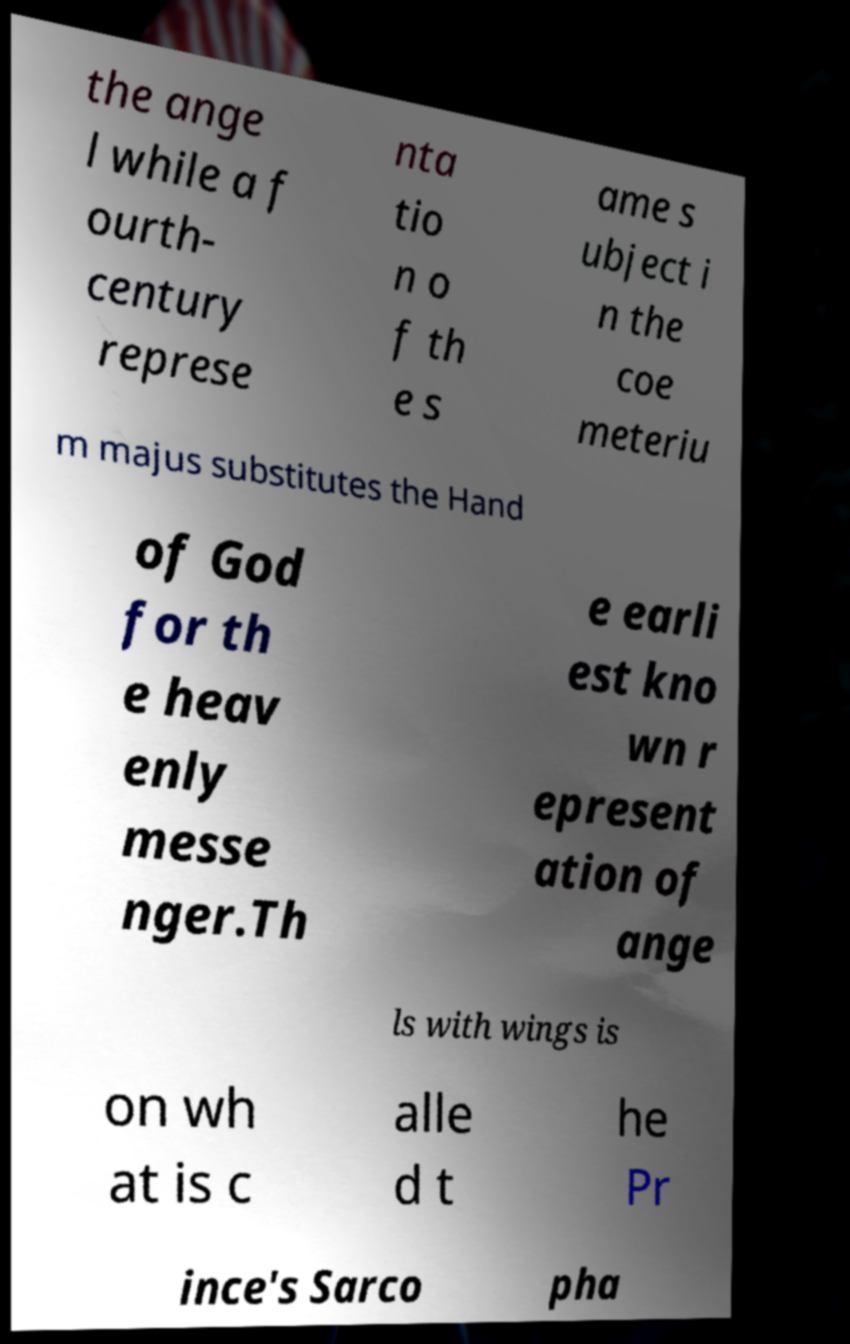There's text embedded in this image that I need extracted. Can you transcribe it verbatim? the ange l while a f ourth- century represe nta tio n o f th e s ame s ubject i n the coe meteriu m majus substitutes the Hand of God for th e heav enly messe nger.Th e earli est kno wn r epresent ation of ange ls with wings is on wh at is c alle d t he Pr ince's Sarco pha 